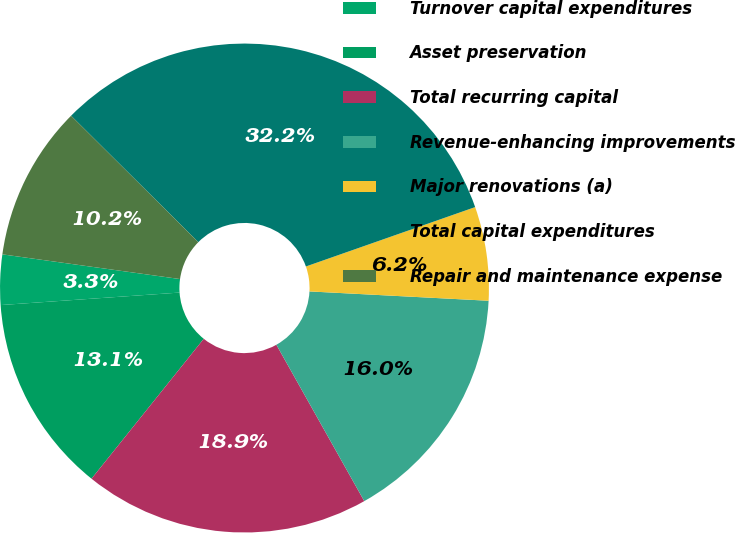<chart> <loc_0><loc_0><loc_500><loc_500><pie_chart><fcel>Turnover capital expenditures<fcel>Asset preservation<fcel>Total recurring capital<fcel>Revenue-enhancing improvements<fcel>Major renovations (a)<fcel>Total capital expenditures<fcel>Repair and maintenance expense<nl><fcel>3.31%<fcel>13.13%<fcel>18.91%<fcel>16.02%<fcel>6.2%<fcel>32.18%<fcel>10.25%<nl></chart> 